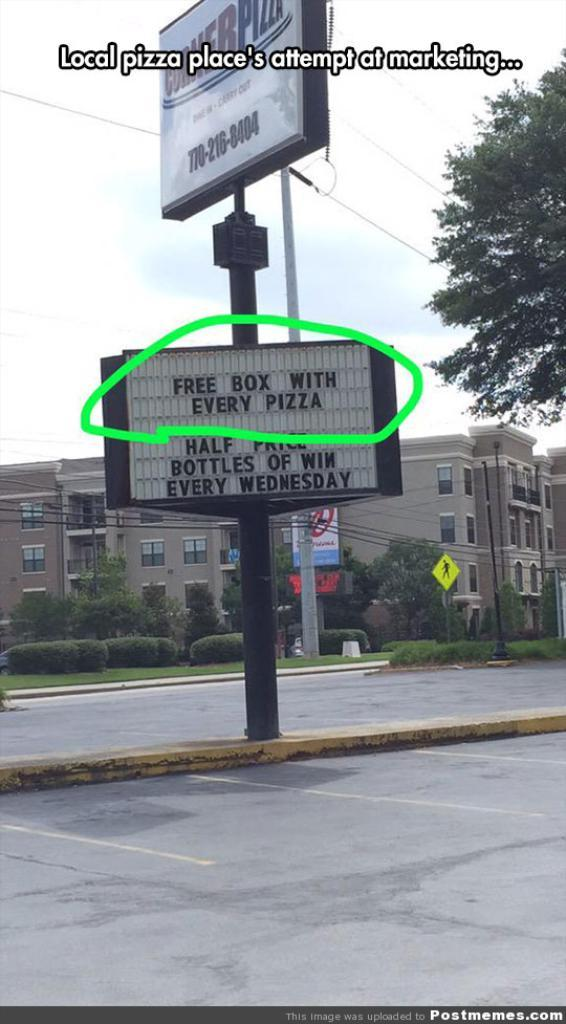Provide a one-sentence caption for the provided image. a sign claiming to give a free box with pizza. 